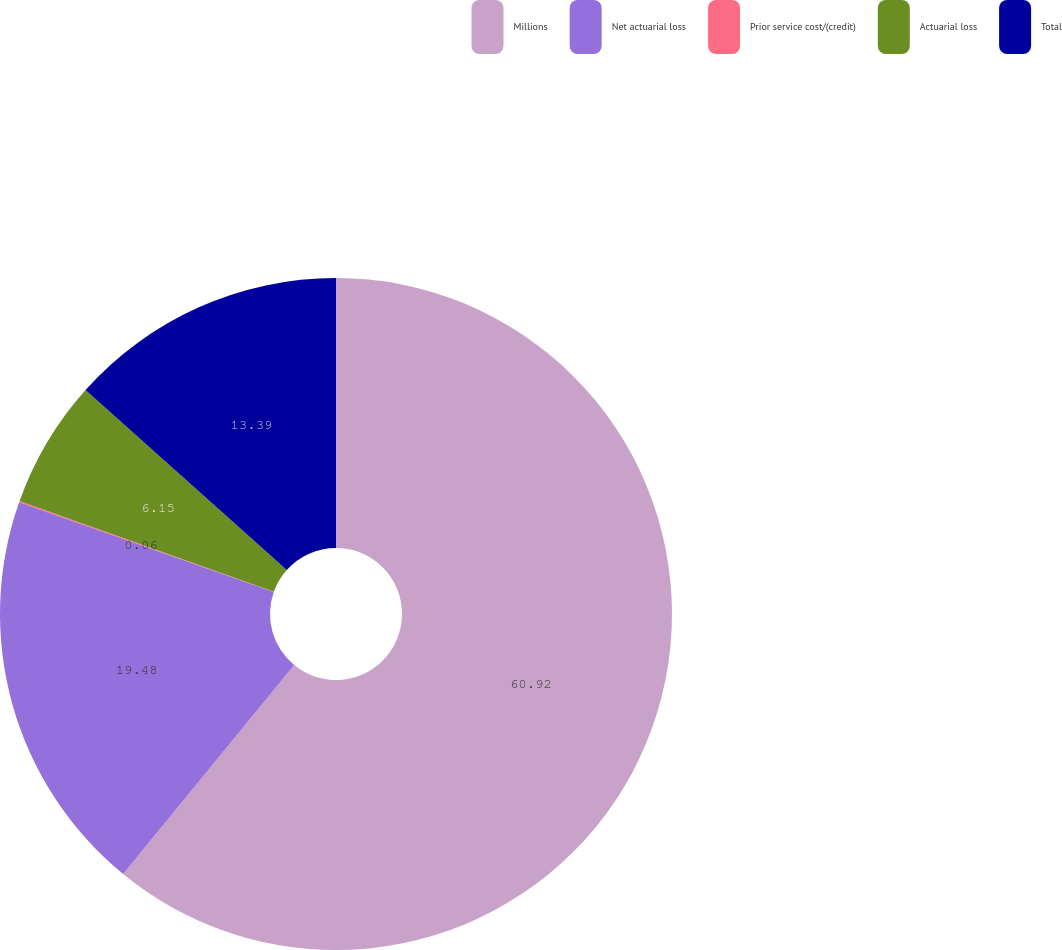Convert chart to OTSL. <chart><loc_0><loc_0><loc_500><loc_500><pie_chart><fcel>Millions<fcel>Net actuarial loss<fcel>Prior service cost/(credit)<fcel>Actuarial loss<fcel>Total<nl><fcel>60.92%<fcel>19.48%<fcel>0.06%<fcel>6.15%<fcel>13.39%<nl></chart> 